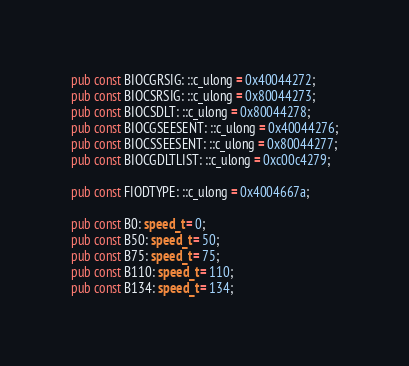<code> <loc_0><loc_0><loc_500><loc_500><_Rust_>pub const BIOCGRSIG: ::c_ulong = 0x40044272;
pub const BIOCSRSIG: ::c_ulong = 0x80044273;
pub const BIOCSDLT: ::c_ulong = 0x80044278;
pub const BIOCGSEESENT: ::c_ulong = 0x40044276;
pub const BIOCSSEESENT: ::c_ulong = 0x80044277;
pub const BIOCGDLTLIST: ::c_ulong = 0xc00c4279;

pub const FIODTYPE: ::c_ulong = 0x4004667a;

pub const B0: speed_t = 0;
pub const B50: speed_t = 50;
pub const B75: speed_t = 75;
pub const B110: speed_t = 110;
pub const B134: speed_t = 134;</code> 